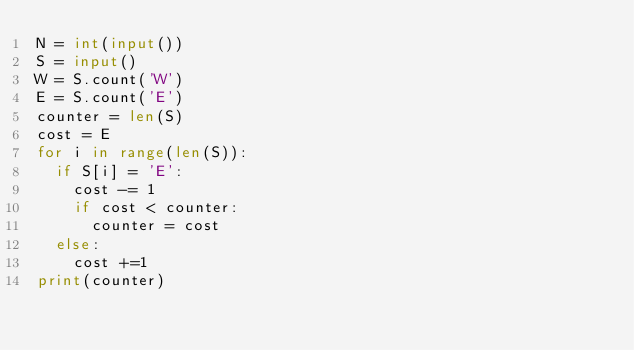<code> <loc_0><loc_0><loc_500><loc_500><_Python_>N = int(input())
S = input()
W = S.count('W')
E = S.count('E')
counter = len(S)
cost = E
for i in range(len(S)):
  if S[i] = 'E':
    cost -= 1
    if cost < counter:
      counter = cost
  else:
    cost +=1
print(counter)</code> 